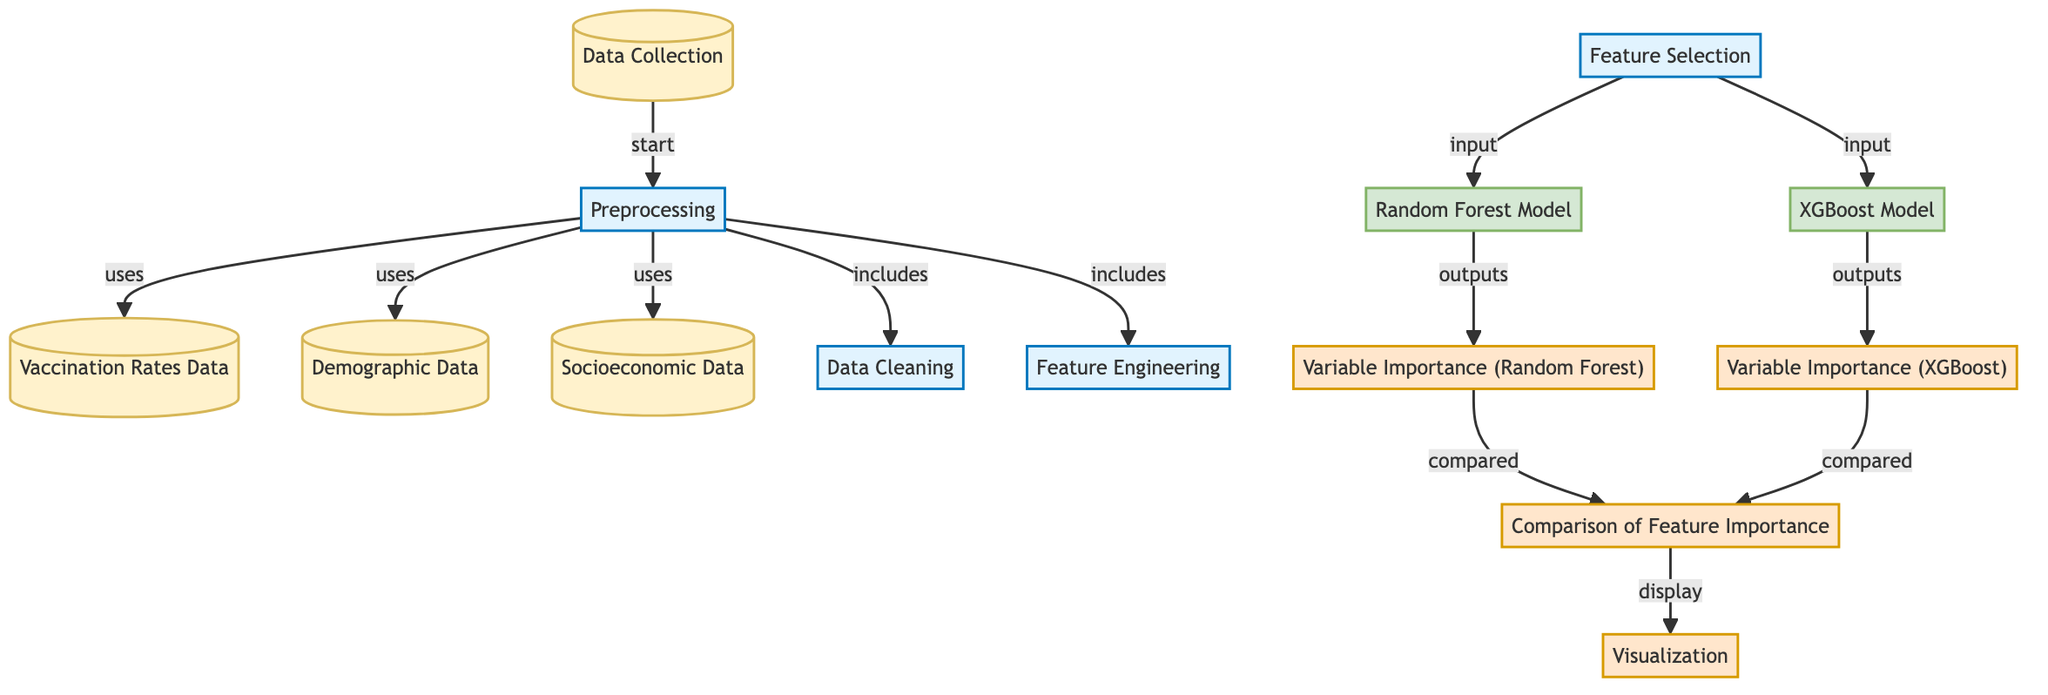What are the three types of data used in this diagram? The diagram displays three types of data involved in the process: Vaccination Rates Data, Demographic Data, and Socioeconomic Data. These nodes are explicitly labeled in the diagram.
Answer: Vaccination Rates Data, Demographic Data, Socioeconomic Data Which nodes are responsible for model generation? The nodes responsible for model generation in the diagram are the Random Forest Model and XGBoost Model. These nodes are specifically designated as model nodes in the flowchart.
Answer: Random Forest Model, XGBoost Model How many nodes are involved in the preprocessing steps? There are four nodes that pertain to the preprocessing steps: Preprocessing, Data Cleaning, Feature Selection, and Feature Engineering. The preprocessing is initiated from the Preprocessing node, and it includes the other three nodes.
Answer: Four What is the output generated by the Random Forest Model? The output generated by the Random Forest Model is the Variable Importance for Random Forest. This output node is directly connected to the Random Forest Model node, indicating the result of its processing.
Answer: Variable Importance (Random Forest) What connects the Variable Importance outputs to the Comparison of Feature Importance? Both Variable Importance (Random Forest) and Variable Importance (XGBoost) outputs are connected to the Comparison of Feature Importance node. This indicates that the comparison analysis is based on the variable importance metrics produced by both models.
Answer: Variable Importance (Random Forest) and Variable Importance (XGBoost) How does data flow from Data Collection to Visualization? The flow starts at Data Collection, which feeds into the Preprocessing stage. After preprocessing, it leads to Feature Selection, which further inputs into the Random Forest Model and XGBoost Model. Both models produce outputs that are then compared, and the comparison is ultimately visualized. Each step is a part of the overall processing flow leading to Visualization.
Answer: Through Data Collection → Preprocessing → Feature Selection → Random Forest Model/XGBoost Model → Comparison of Feature Importance → Visualization Which process involves enhancing the dataset? The process that involves enhancing the dataset is Feature Engineering. This step is aimed at improving the data quality and making it suitable for model training by creating new relevant features.
Answer: Feature Engineering What demonstrates the final output of the diagram? The final output of the diagram is demonstrated by the Visualization node. It encapsulates the results of the whole process visually, allowing for easier interpretation and analysis of the data processed through the earlier steps.
Answer: Visualization 